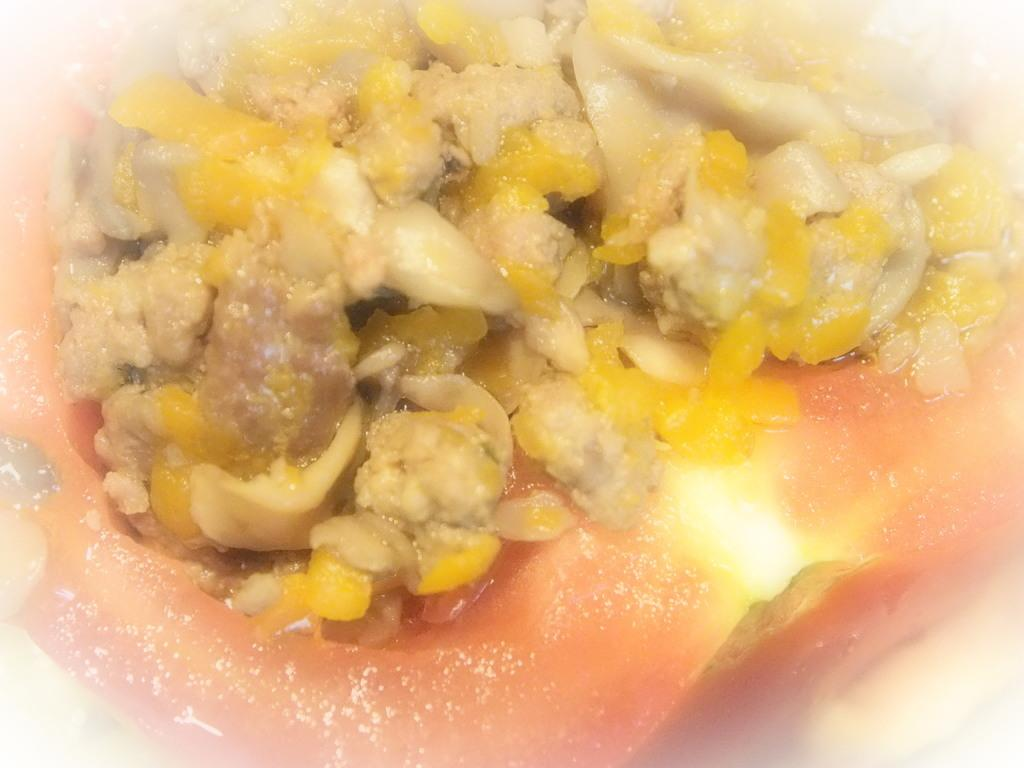What can be seen in the image related to food? There is food visible in the image. What type of wine is being served with the food in the image? There is no wine present in the image; only food is visible. 